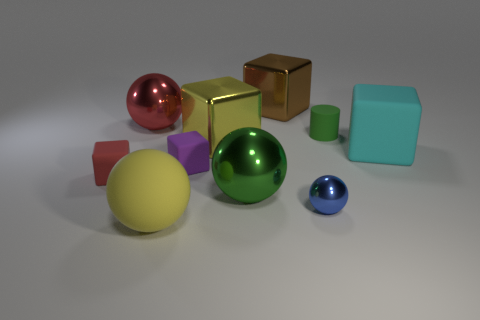Subtract all large rubber blocks. How many blocks are left? 4 Subtract all brown blocks. How many blocks are left? 4 Subtract all gray cubes. Subtract all yellow spheres. How many cubes are left? 5 Subtract all cylinders. How many objects are left? 9 Subtract 1 green balls. How many objects are left? 9 Subtract all tiny cyan matte things. Subtract all brown blocks. How many objects are left? 9 Add 8 yellow shiny things. How many yellow shiny things are left? 9 Add 3 big yellow blocks. How many big yellow blocks exist? 4 